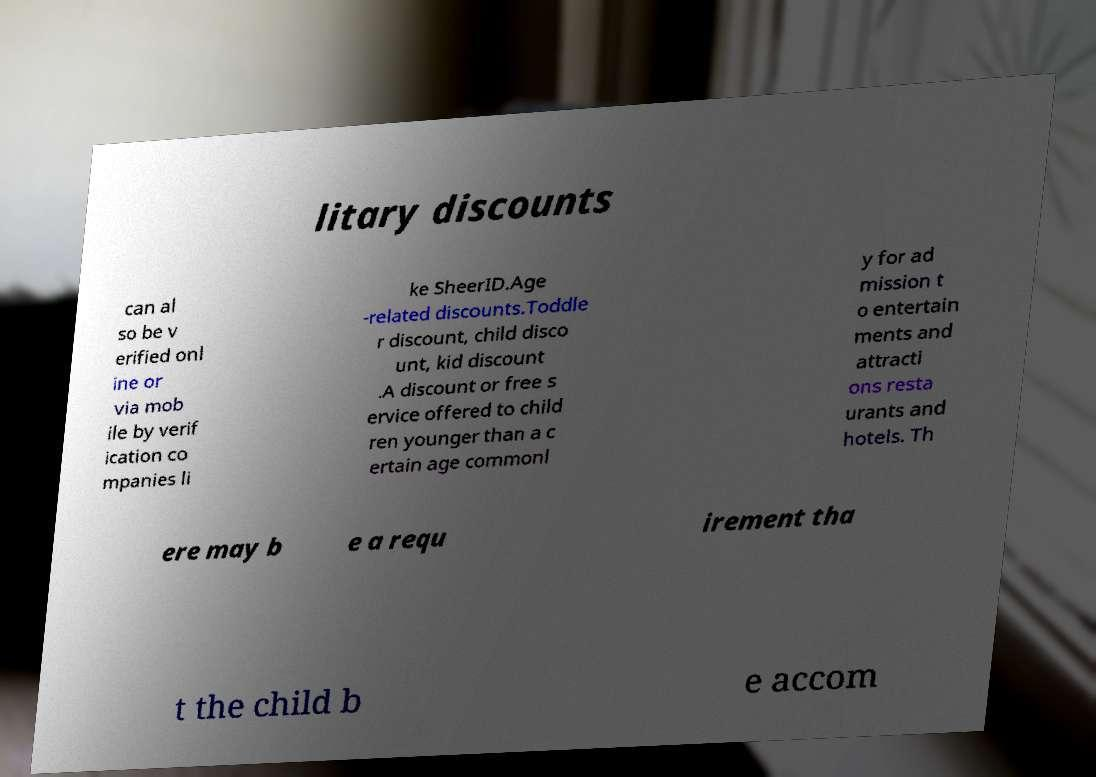Could you extract and type out the text from this image? litary discounts can al so be v erified onl ine or via mob ile by verif ication co mpanies li ke SheerID.Age -related discounts.Toddle r discount, child disco unt, kid discount .A discount or free s ervice offered to child ren younger than a c ertain age commonl y for ad mission t o entertain ments and attracti ons resta urants and hotels. Th ere may b e a requ irement tha t the child b e accom 